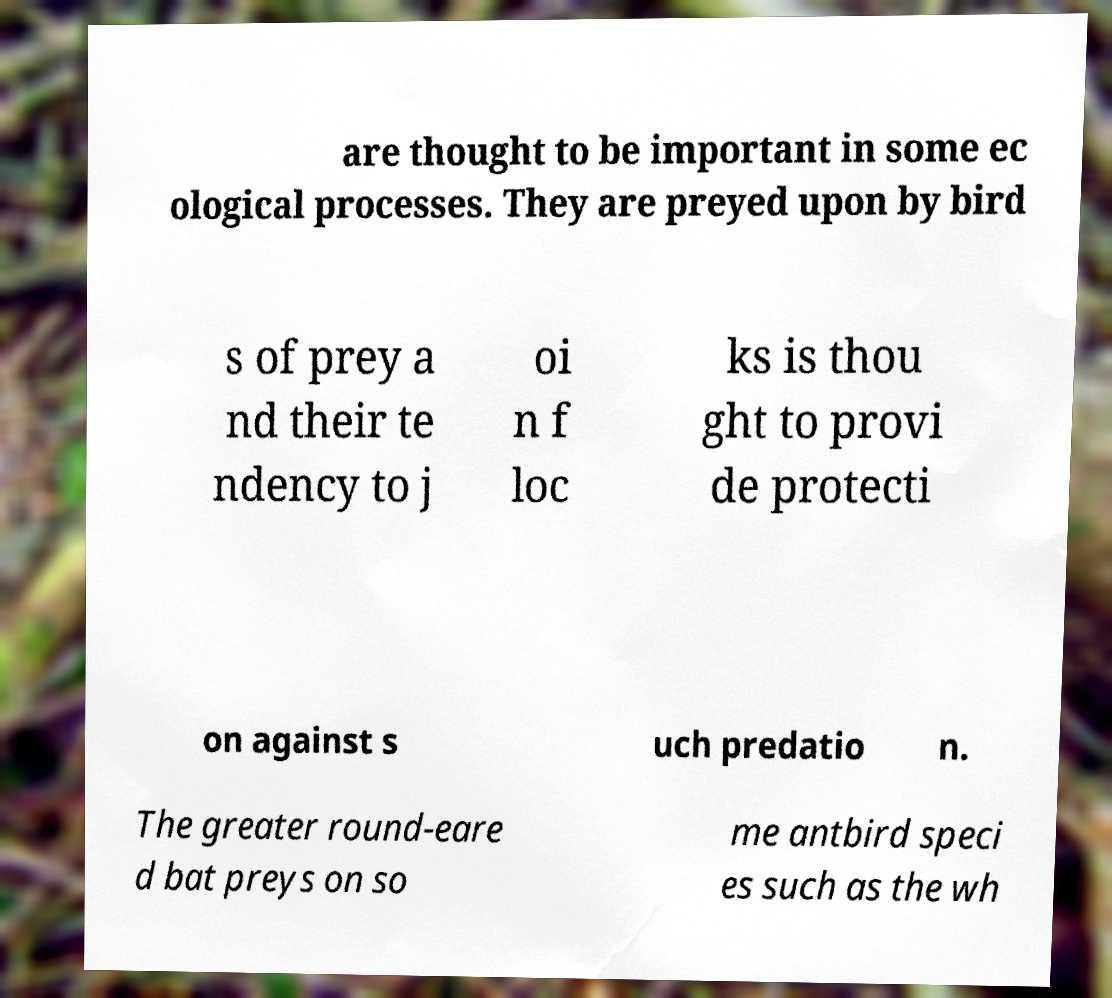There's text embedded in this image that I need extracted. Can you transcribe it verbatim? are thought to be important in some ec ological processes. They are preyed upon by bird s of prey a nd their te ndency to j oi n f loc ks is thou ght to provi de protecti on against s uch predatio n. The greater round-eare d bat preys on so me antbird speci es such as the wh 